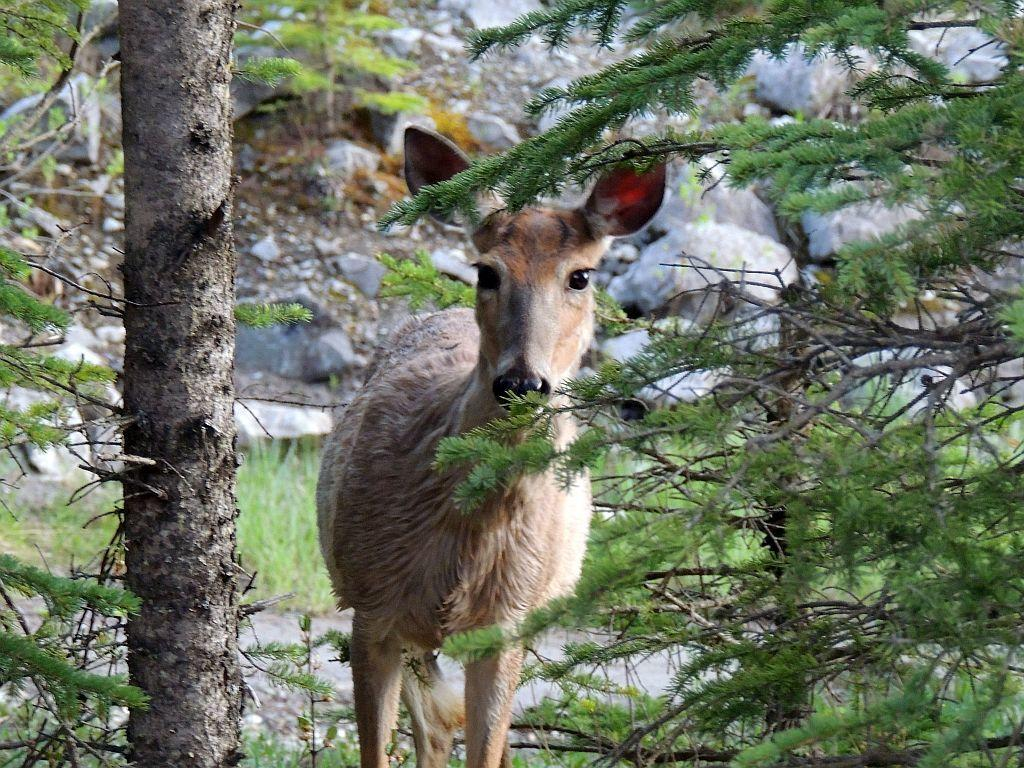What is the main subject in the center of the image? There is an animal in the center of the image. What part of a tree can be seen in the image? The bark of a tree is visible in the image. What type of vegetation is present in the image? There are plants in the image. What type of natural material is present in the image? Stones are present in the image. What else from trees can be seen in the image? Branches of trees are visible in the image. What type of jelly is being used to decorate the animal in the image? There is no jelly present in the image, and the animal is not being decorated. 